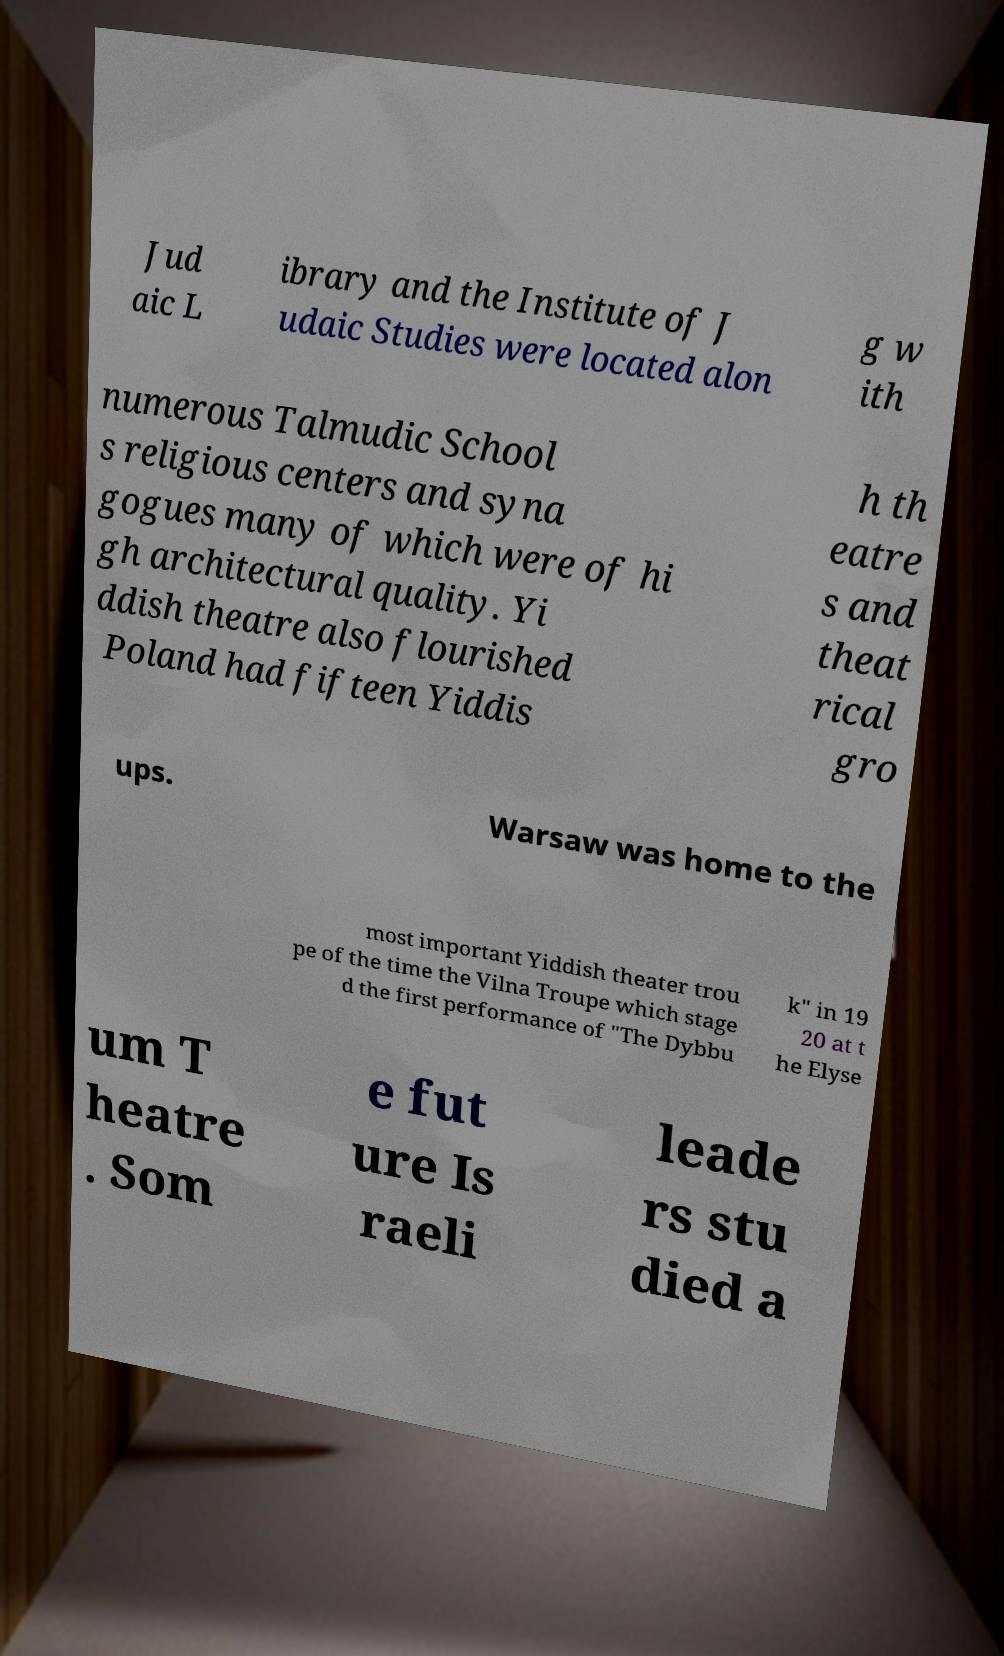There's text embedded in this image that I need extracted. Can you transcribe it verbatim? Jud aic L ibrary and the Institute of J udaic Studies were located alon g w ith numerous Talmudic School s religious centers and syna gogues many of which were of hi gh architectural quality. Yi ddish theatre also flourished Poland had fifteen Yiddis h th eatre s and theat rical gro ups. Warsaw was home to the most important Yiddish theater trou pe of the time the Vilna Troupe which stage d the first performance of "The Dybbu k" in 19 20 at t he Elyse um T heatre . Som e fut ure Is raeli leade rs stu died a 